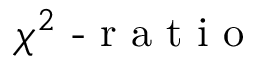Convert formula to latex. <formula><loc_0><loc_0><loc_500><loc_500>\chi ^ { 2 } - r a t i o</formula> 